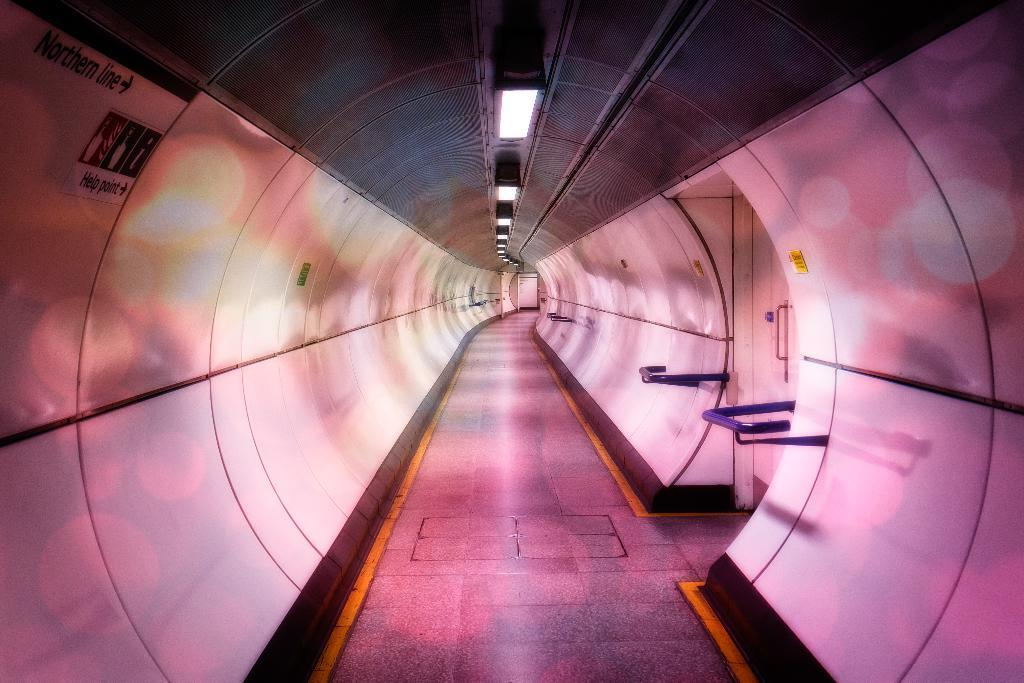What is the main subject of the image? The main subject of the image is a tunnel. What word is used to describe the sound of a balloon bursting in the image? There is no balloon or sound in the image, as it only features a tunnel. 